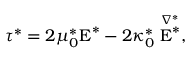Convert formula to latex. <formula><loc_0><loc_0><loc_500><loc_500>\tau ^ { * } = 2 \mu _ { 0 } ^ { * } E ^ { * } - 2 \kappa _ { 0 } ^ { * } \stackrel { \nabla ^ { * } } { E ^ { * } } ,</formula> 